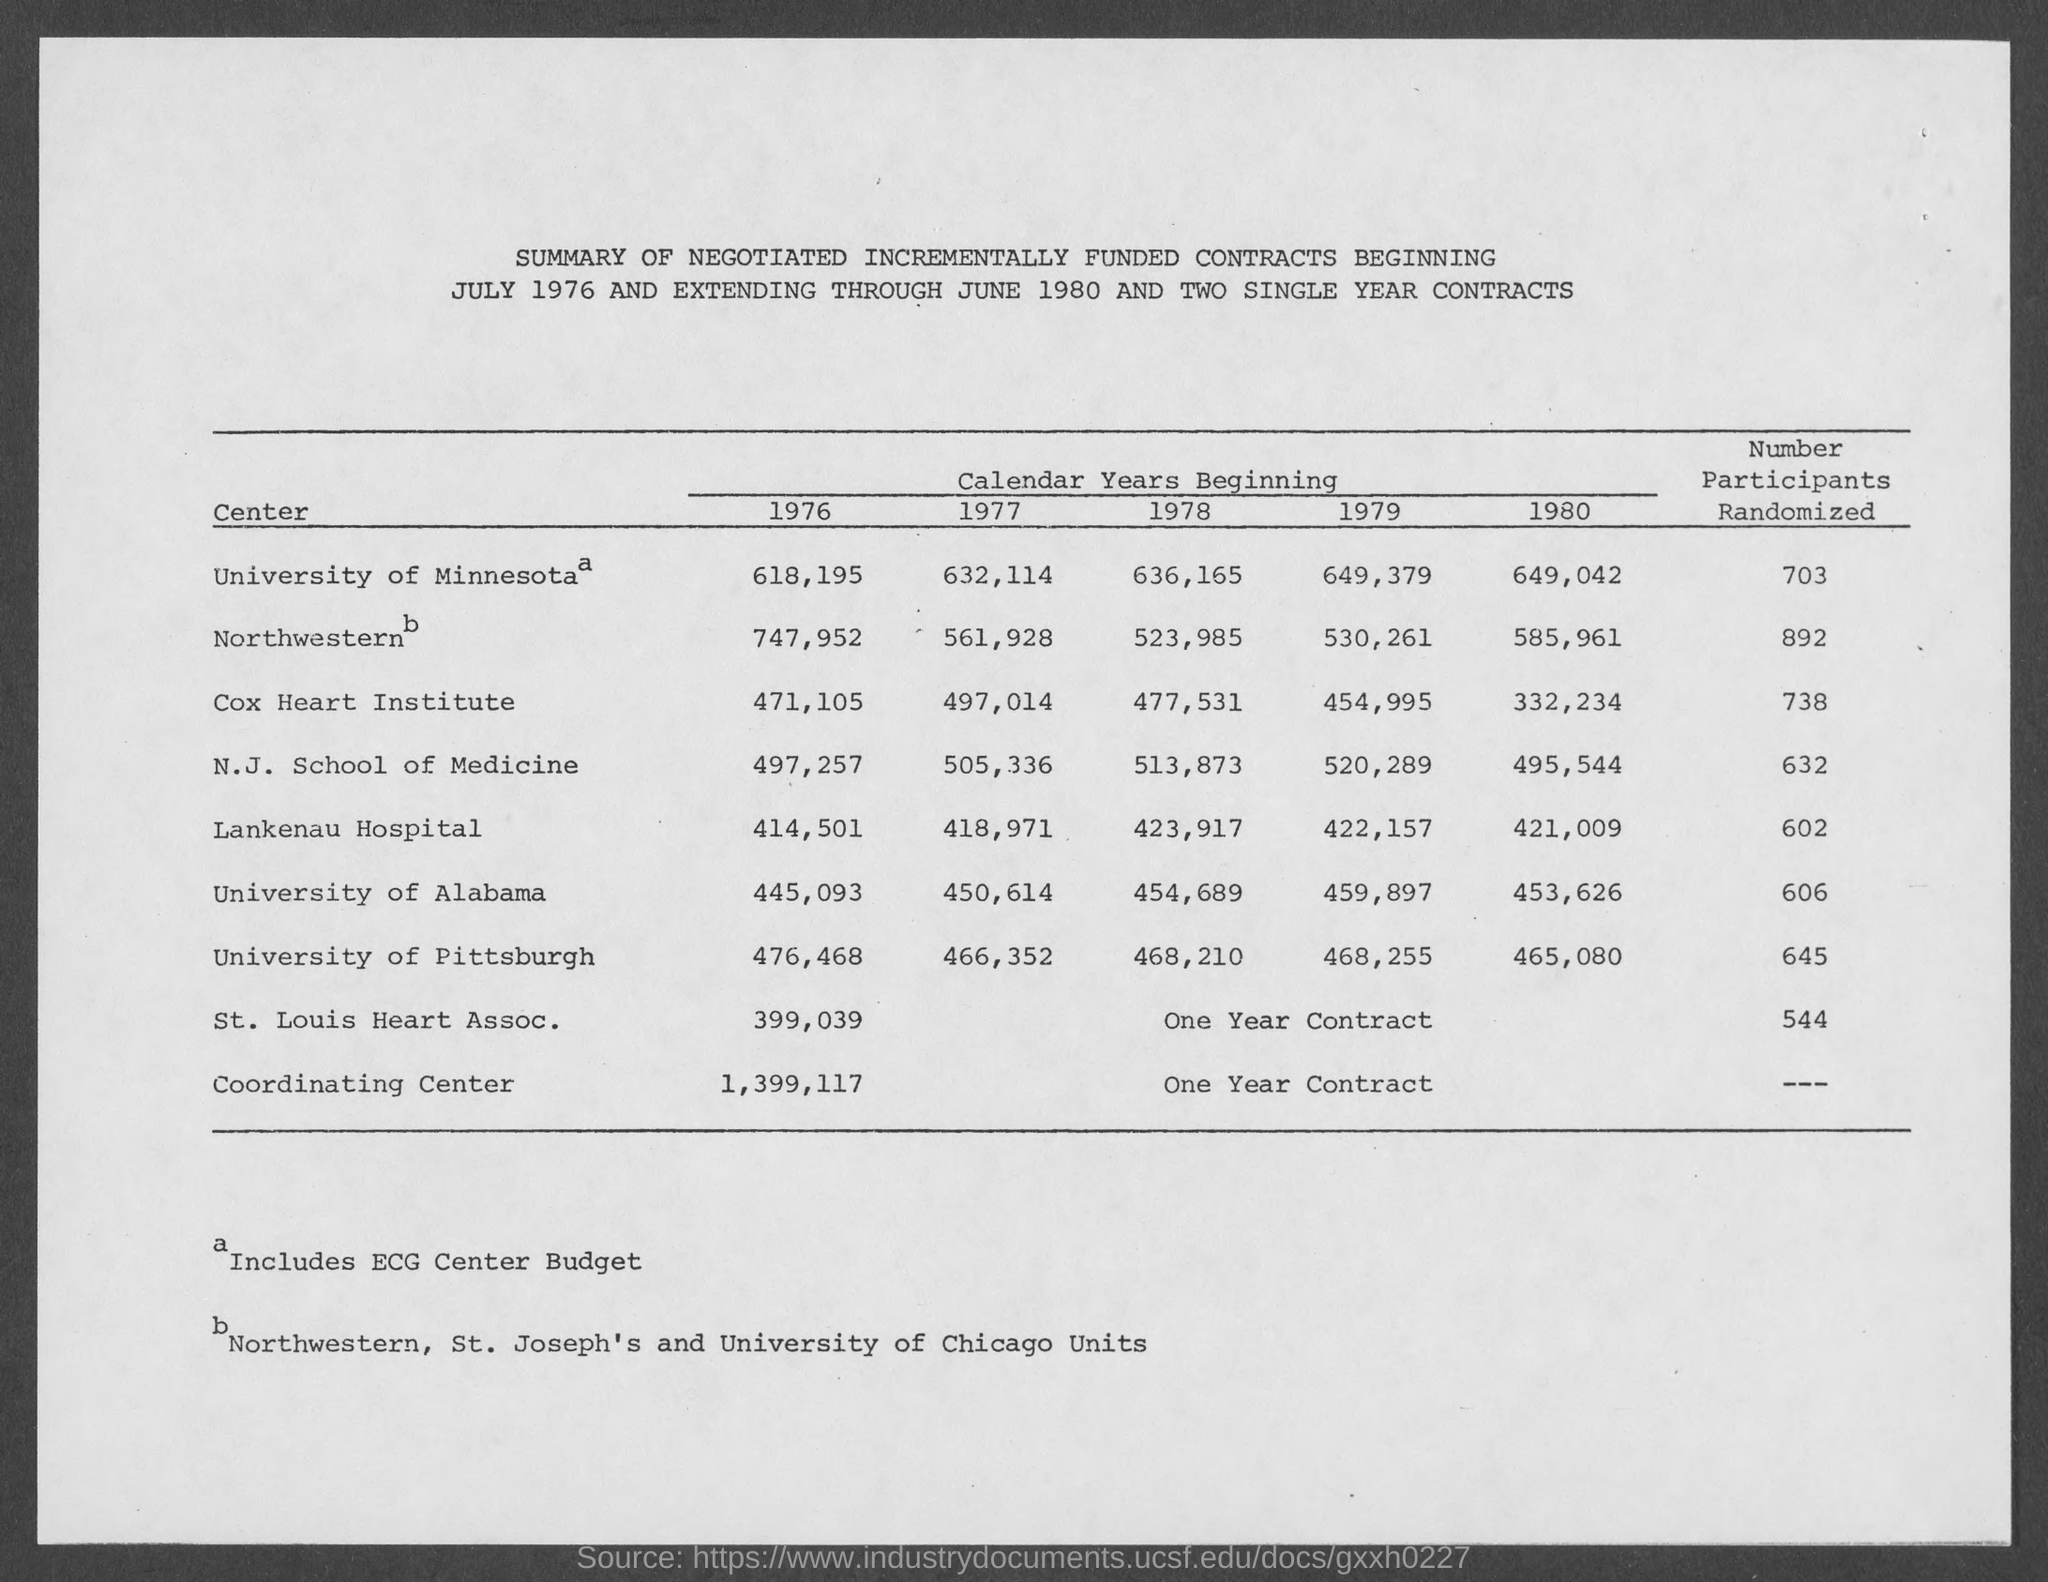Identify some key points in this picture. There were 738 participants from the Cox Heart Institute. The number of participants from the University of Minnesota is 703. There were 645 participants from the University of Pittsburgh. 